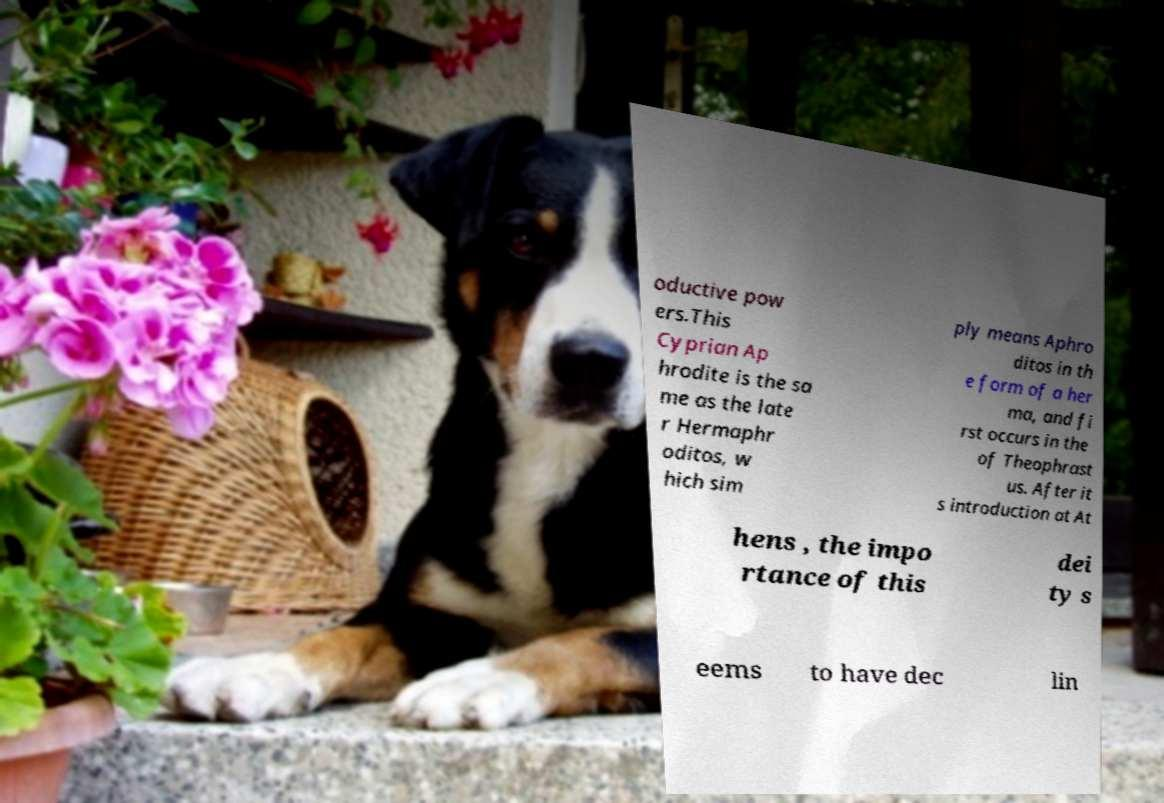Could you assist in decoding the text presented in this image and type it out clearly? oductive pow ers.This Cyprian Ap hrodite is the sa me as the late r Hermaphr oditos, w hich sim ply means Aphro ditos in th e form of a her ma, and fi rst occurs in the of Theophrast us. After it s introduction at At hens , the impo rtance of this dei ty s eems to have dec lin 